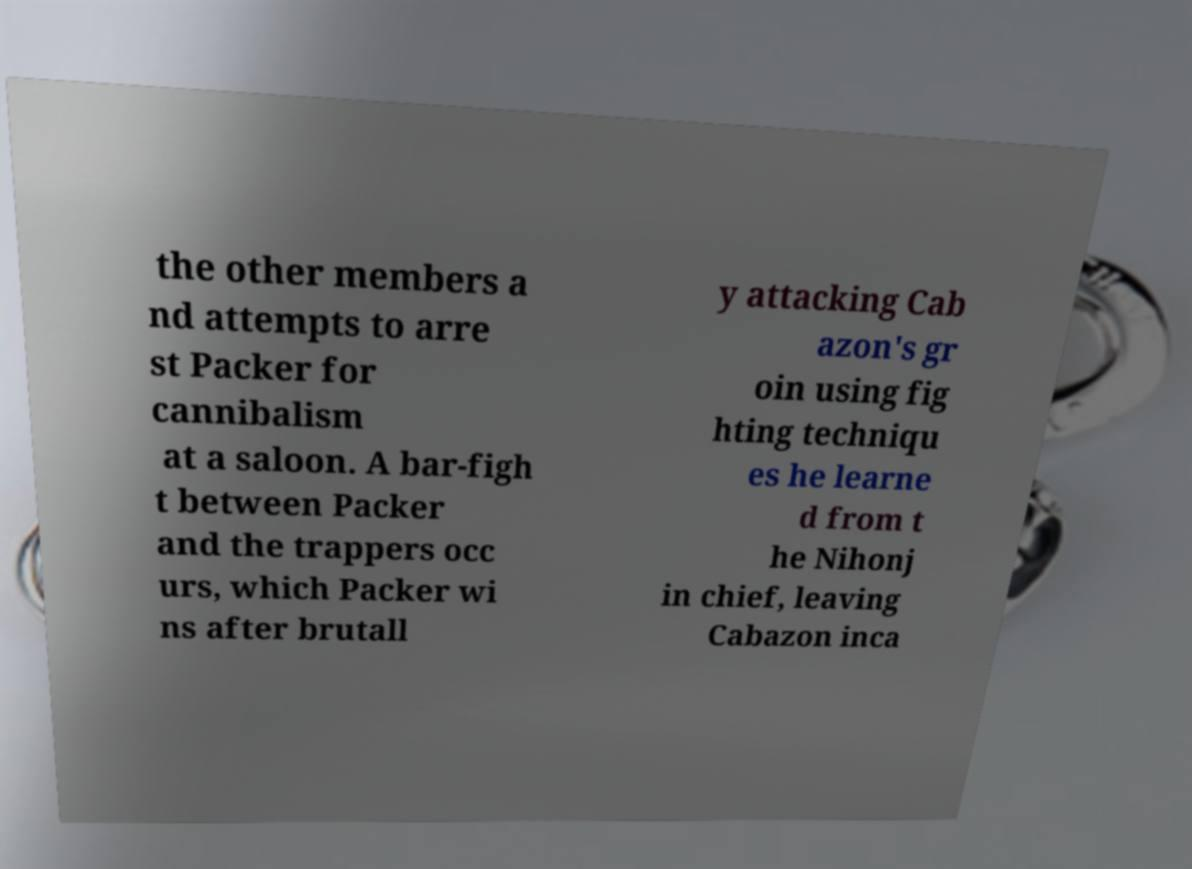What messages or text are displayed in this image? I need them in a readable, typed format. the other members a nd attempts to arre st Packer for cannibalism at a saloon. A bar-figh t between Packer and the trappers occ urs, which Packer wi ns after brutall y attacking Cab azon's gr oin using fig hting techniqu es he learne d from t he Nihonj in chief, leaving Cabazon inca 